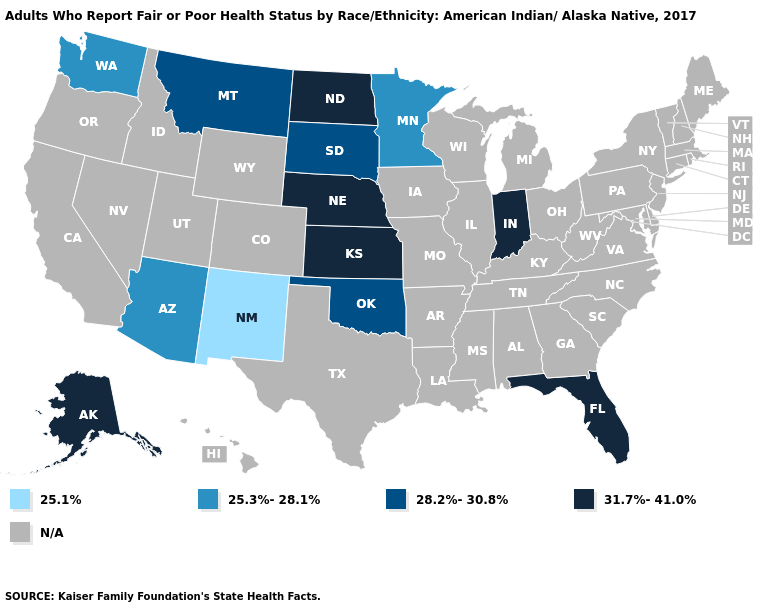Does Oklahoma have the highest value in the South?
Keep it brief. No. Which states have the lowest value in the USA?
Quick response, please. New Mexico. Does the first symbol in the legend represent the smallest category?
Keep it brief. Yes. Does Oklahoma have the lowest value in the USA?
Answer briefly. No. Does Florida have the lowest value in the South?
Keep it brief. No. Does New Mexico have the lowest value in the USA?
Quick response, please. Yes. Is the legend a continuous bar?
Quick response, please. No. What is the value of Rhode Island?
Give a very brief answer. N/A. Which states have the lowest value in the USA?
Write a very short answer. New Mexico. What is the value of Mississippi?
Short answer required. N/A. Name the states that have a value in the range N/A?
Short answer required. Alabama, Arkansas, California, Colorado, Connecticut, Delaware, Georgia, Hawaii, Idaho, Illinois, Iowa, Kentucky, Louisiana, Maine, Maryland, Massachusetts, Michigan, Mississippi, Missouri, Nevada, New Hampshire, New Jersey, New York, North Carolina, Ohio, Oregon, Pennsylvania, Rhode Island, South Carolina, Tennessee, Texas, Utah, Vermont, Virginia, West Virginia, Wisconsin, Wyoming. 